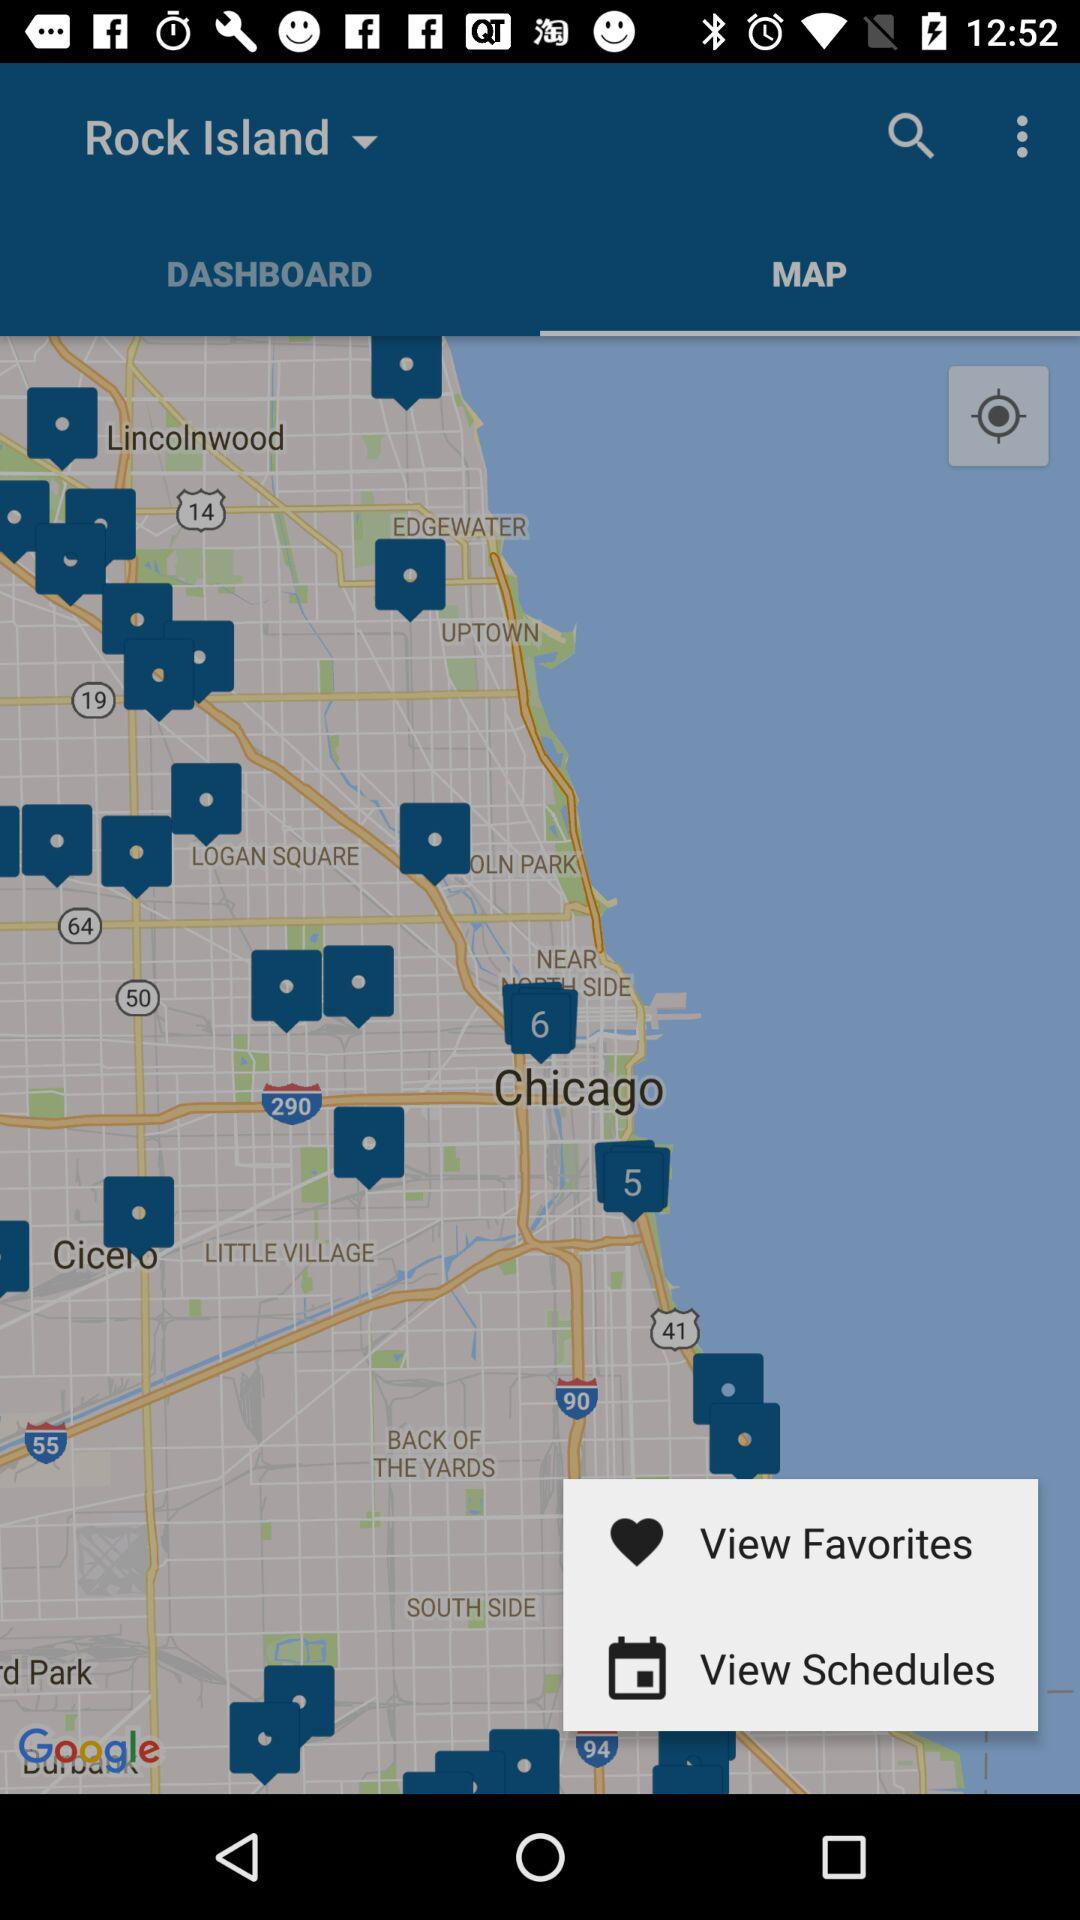Which tab is selected? The selected tab is "MAP". 